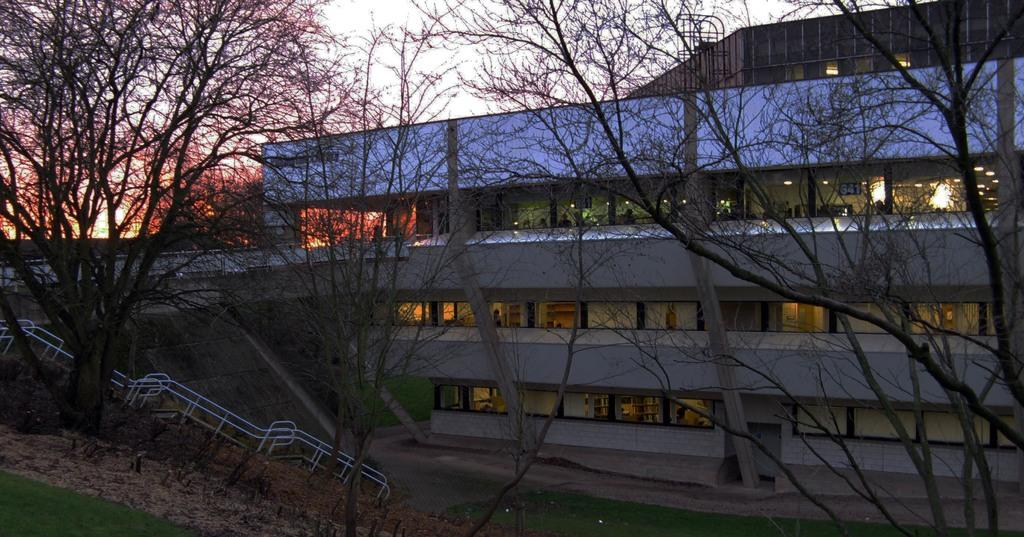What is located in the center of the image? In the center of the image, there are trees, grass, lights, pillars, a fence, a building, and a wall. What can be seen in the background of the image? In the background of the image, the sky and clouds are visible. Are there any people present in the image? Yes, there are people standing in the center of the image. What rhythm is being played by the trees in the image? There is no rhythm being played by the trees in the image, as trees do not produce music or rhythm. What idea is being expressed by the clouds in the image? There is no idea being expressed by the clouds in the image, as clouds are a natural atmospheric phenomenon and do not convey ideas or concepts. 